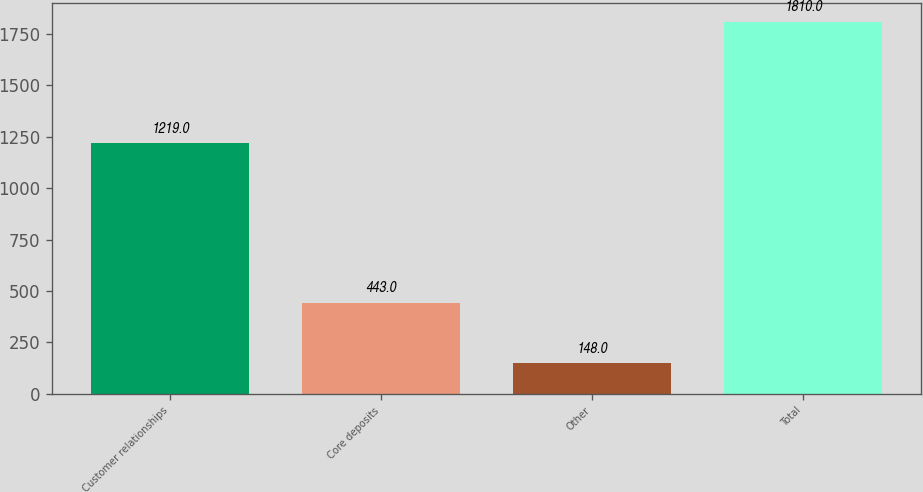<chart> <loc_0><loc_0><loc_500><loc_500><bar_chart><fcel>Customer relationships<fcel>Core deposits<fcel>Other<fcel>Total<nl><fcel>1219<fcel>443<fcel>148<fcel>1810<nl></chart> 